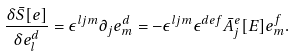<formula> <loc_0><loc_0><loc_500><loc_500>\frac { \delta { \bar { S } } [ e ] } { \delta e _ { l } ^ { d } } = \epsilon ^ { l j m } \partial _ { j } e _ { m } ^ { d } = - \epsilon ^ { l j m } \epsilon ^ { d e f } { \bar { A } } _ { j } ^ { e } [ E ] e _ { m } ^ { f } .</formula> 